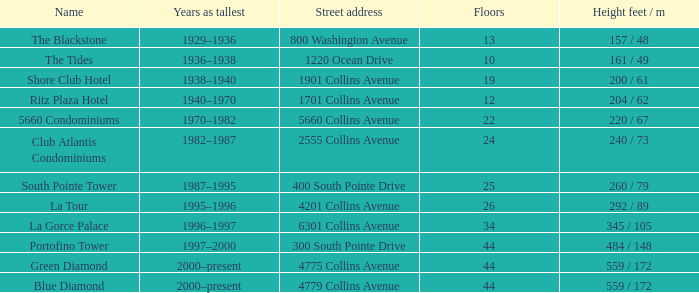How many floors does the Blue Diamond have? 44.0. 